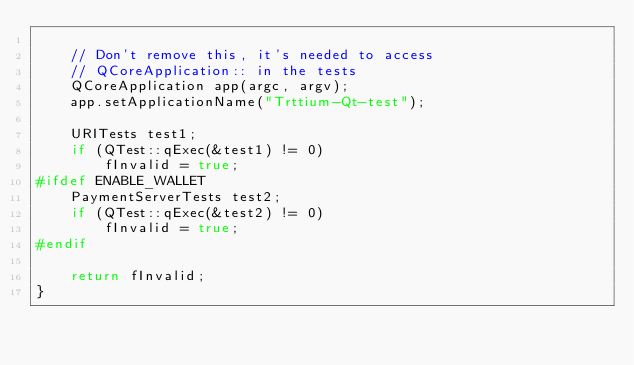<code> <loc_0><loc_0><loc_500><loc_500><_C++_>
    // Don't remove this, it's needed to access
    // QCoreApplication:: in the tests
    QCoreApplication app(argc, argv);
    app.setApplicationName("Trttium-Qt-test");

    URITests test1;
    if (QTest::qExec(&test1) != 0)
        fInvalid = true;
#ifdef ENABLE_WALLET
    PaymentServerTests test2;
    if (QTest::qExec(&test2) != 0)
        fInvalid = true;
#endif

    return fInvalid;
}
</code> 